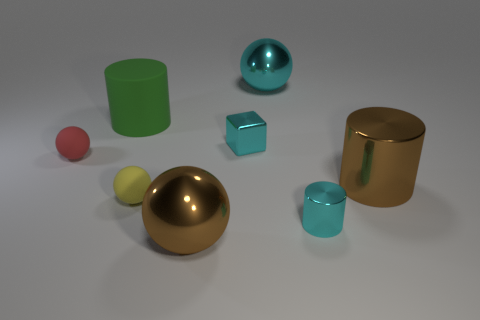Subtract all red spheres. Subtract all cyan cubes. How many spheres are left? 3 Add 1 large objects. How many objects exist? 9 Subtract all cylinders. How many objects are left? 5 Add 3 tiny cyan cylinders. How many tiny cyan cylinders exist? 4 Subtract 0 purple cylinders. How many objects are left? 8 Subtract all large cyan metallic objects. Subtract all red rubber balls. How many objects are left? 6 Add 5 tiny cyan blocks. How many tiny cyan blocks are left? 6 